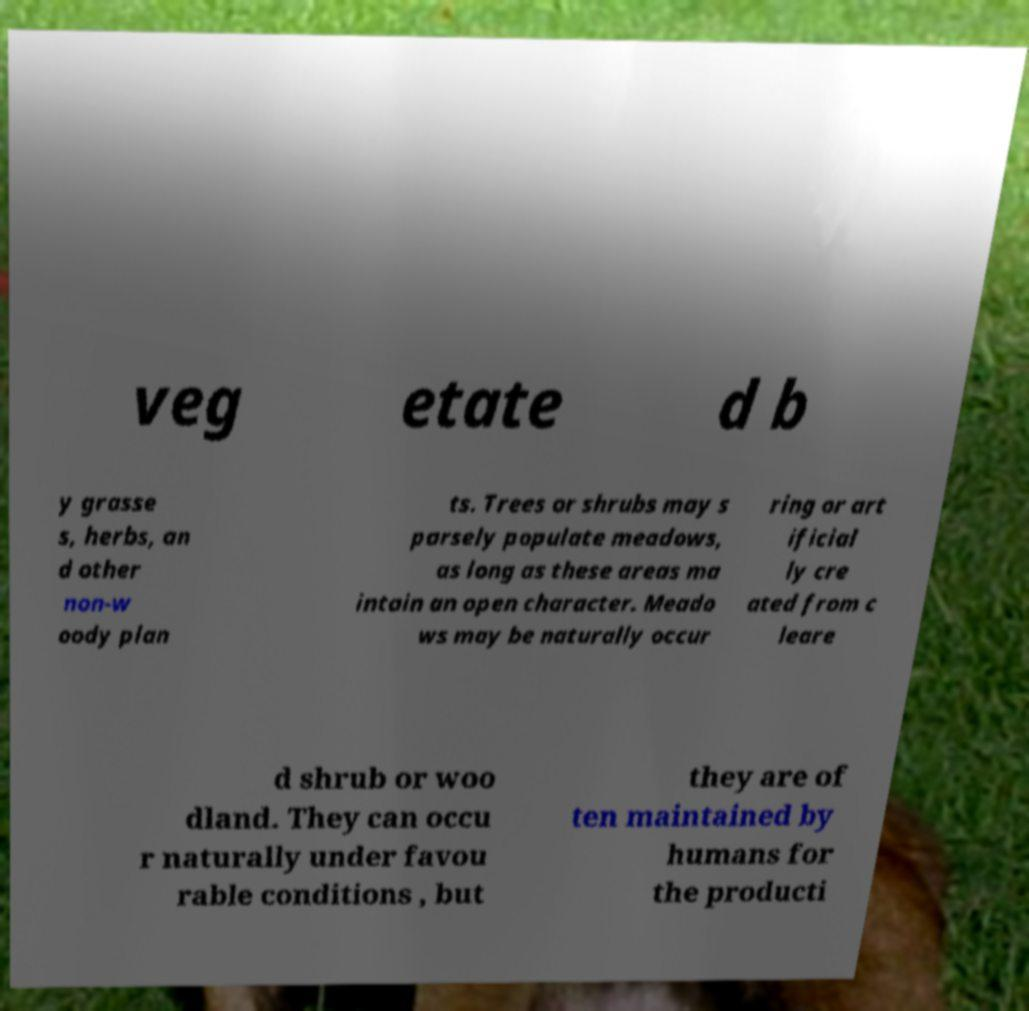Can you read and provide the text displayed in the image?This photo seems to have some interesting text. Can you extract and type it out for me? veg etate d b y grasse s, herbs, an d other non-w oody plan ts. Trees or shrubs may s parsely populate meadows, as long as these areas ma intain an open character. Meado ws may be naturally occur ring or art ificial ly cre ated from c leare d shrub or woo dland. They can occu r naturally under favou rable conditions , but they are of ten maintained by humans for the producti 